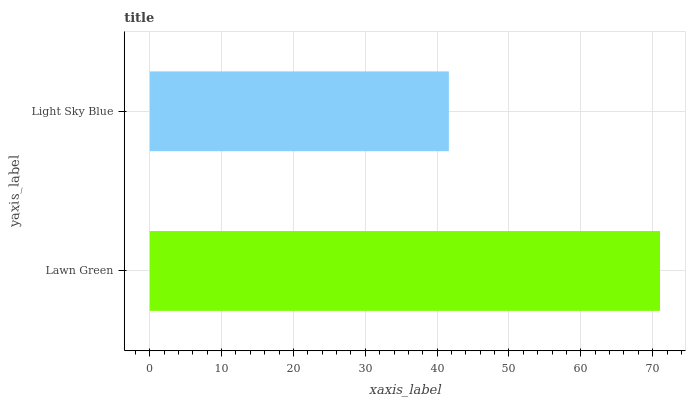Is Light Sky Blue the minimum?
Answer yes or no. Yes. Is Lawn Green the maximum?
Answer yes or no. Yes. Is Light Sky Blue the maximum?
Answer yes or no. No. Is Lawn Green greater than Light Sky Blue?
Answer yes or no. Yes. Is Light Sky Blue less than Lawn Green?
Answer yes or no. Yes. Is Light Sky Blue greater than Lawn Green?
Answer yes or no. No. Is Lawn Green less than Light Sky Blue?
Answer yes or no. No. Is Lawn Green the high median?
Answer yes or no. Yes. Is Light Sky Blue the low median?
Answer yes or no. Yes. Is Light Sky Blue the high median?
Answer yes or no. No. Is Lawn Green the low median?
Answer yes or no. No. 